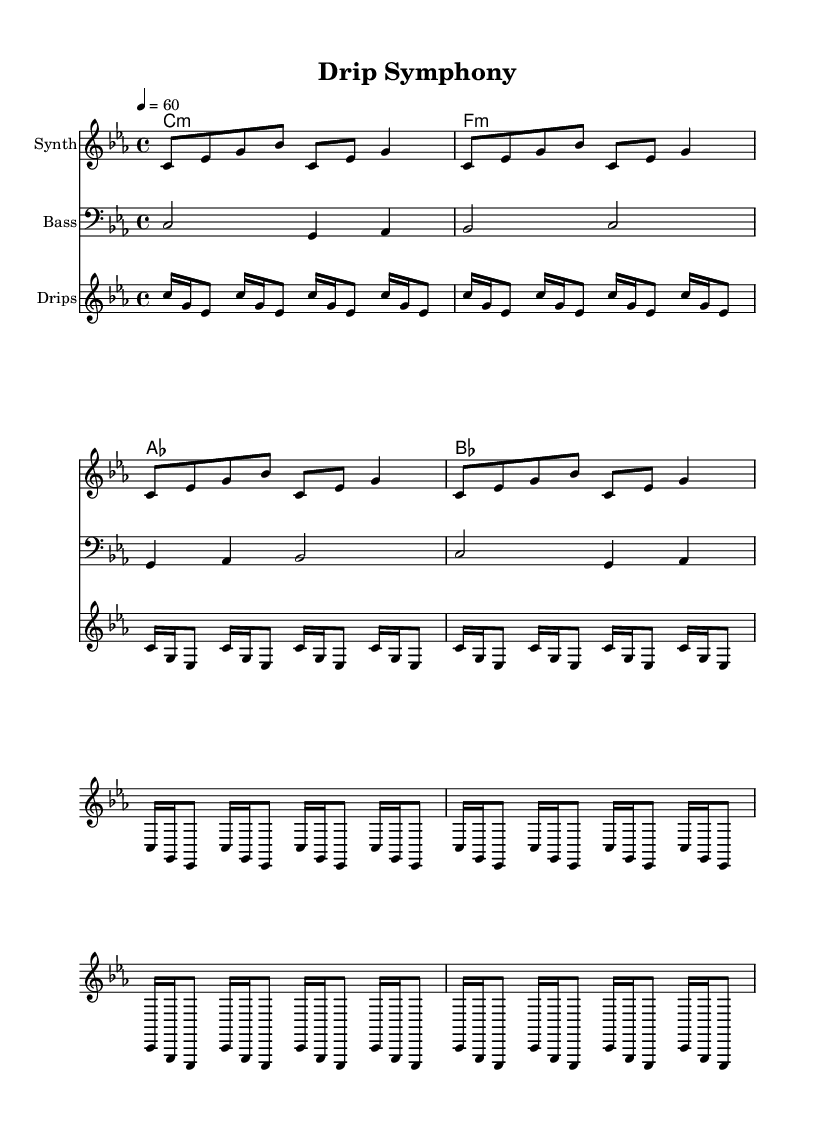What is the key signature of this music? The key signature is C minor, which has three flats (B flat, E flat, and A flat). This can be identified by looking at the key signature marking at the beginning of the score.
Answer: C minor What is the time signature of this music? The time signature is 4/4, which can be found at the beginning of the score. This indicates that there are four beats in each measure, and a quarter note receives one beat.
Answer: 4/4 What is the tempo marking for this piece? The tempo marking is 4 = 60, which indicates the beats per minute for the piece. This means that the quarter note gets 60 beats per minute, serving as a slow tempo.
Answer: 60 How many measures are there in the synth melody? The synth melody consists of 16 measures. Counting the number of bar lines or the structure of the melody helps in determining the total number.
Answer: 16 What musical technique is used to create the drip pattern? The drip pattern employs repetition, specifically unfolding repeated notes in a rhythmic sequence to mimic the sound of dripping water. This technique is common in minimalist music to establish a pattern-like feel.
Answer: Repetition What chord progression is used in the piece? The chord progression used is C minor, F minor, A flat major, and B flat major. This can be observed in the chord names section at the beginning of the score, which outlines the basic harmonic structure.
Answer: C minor, F minor, A flat major, B flat major What type of sound does the bass line primarily focus on? The bass line primarily focuses on melodic notes that create a harmonic foundation for the piece. This is characterized by the alternating pitches that provide depth and support to the synth melody.
Answer: Harmonic foundation 